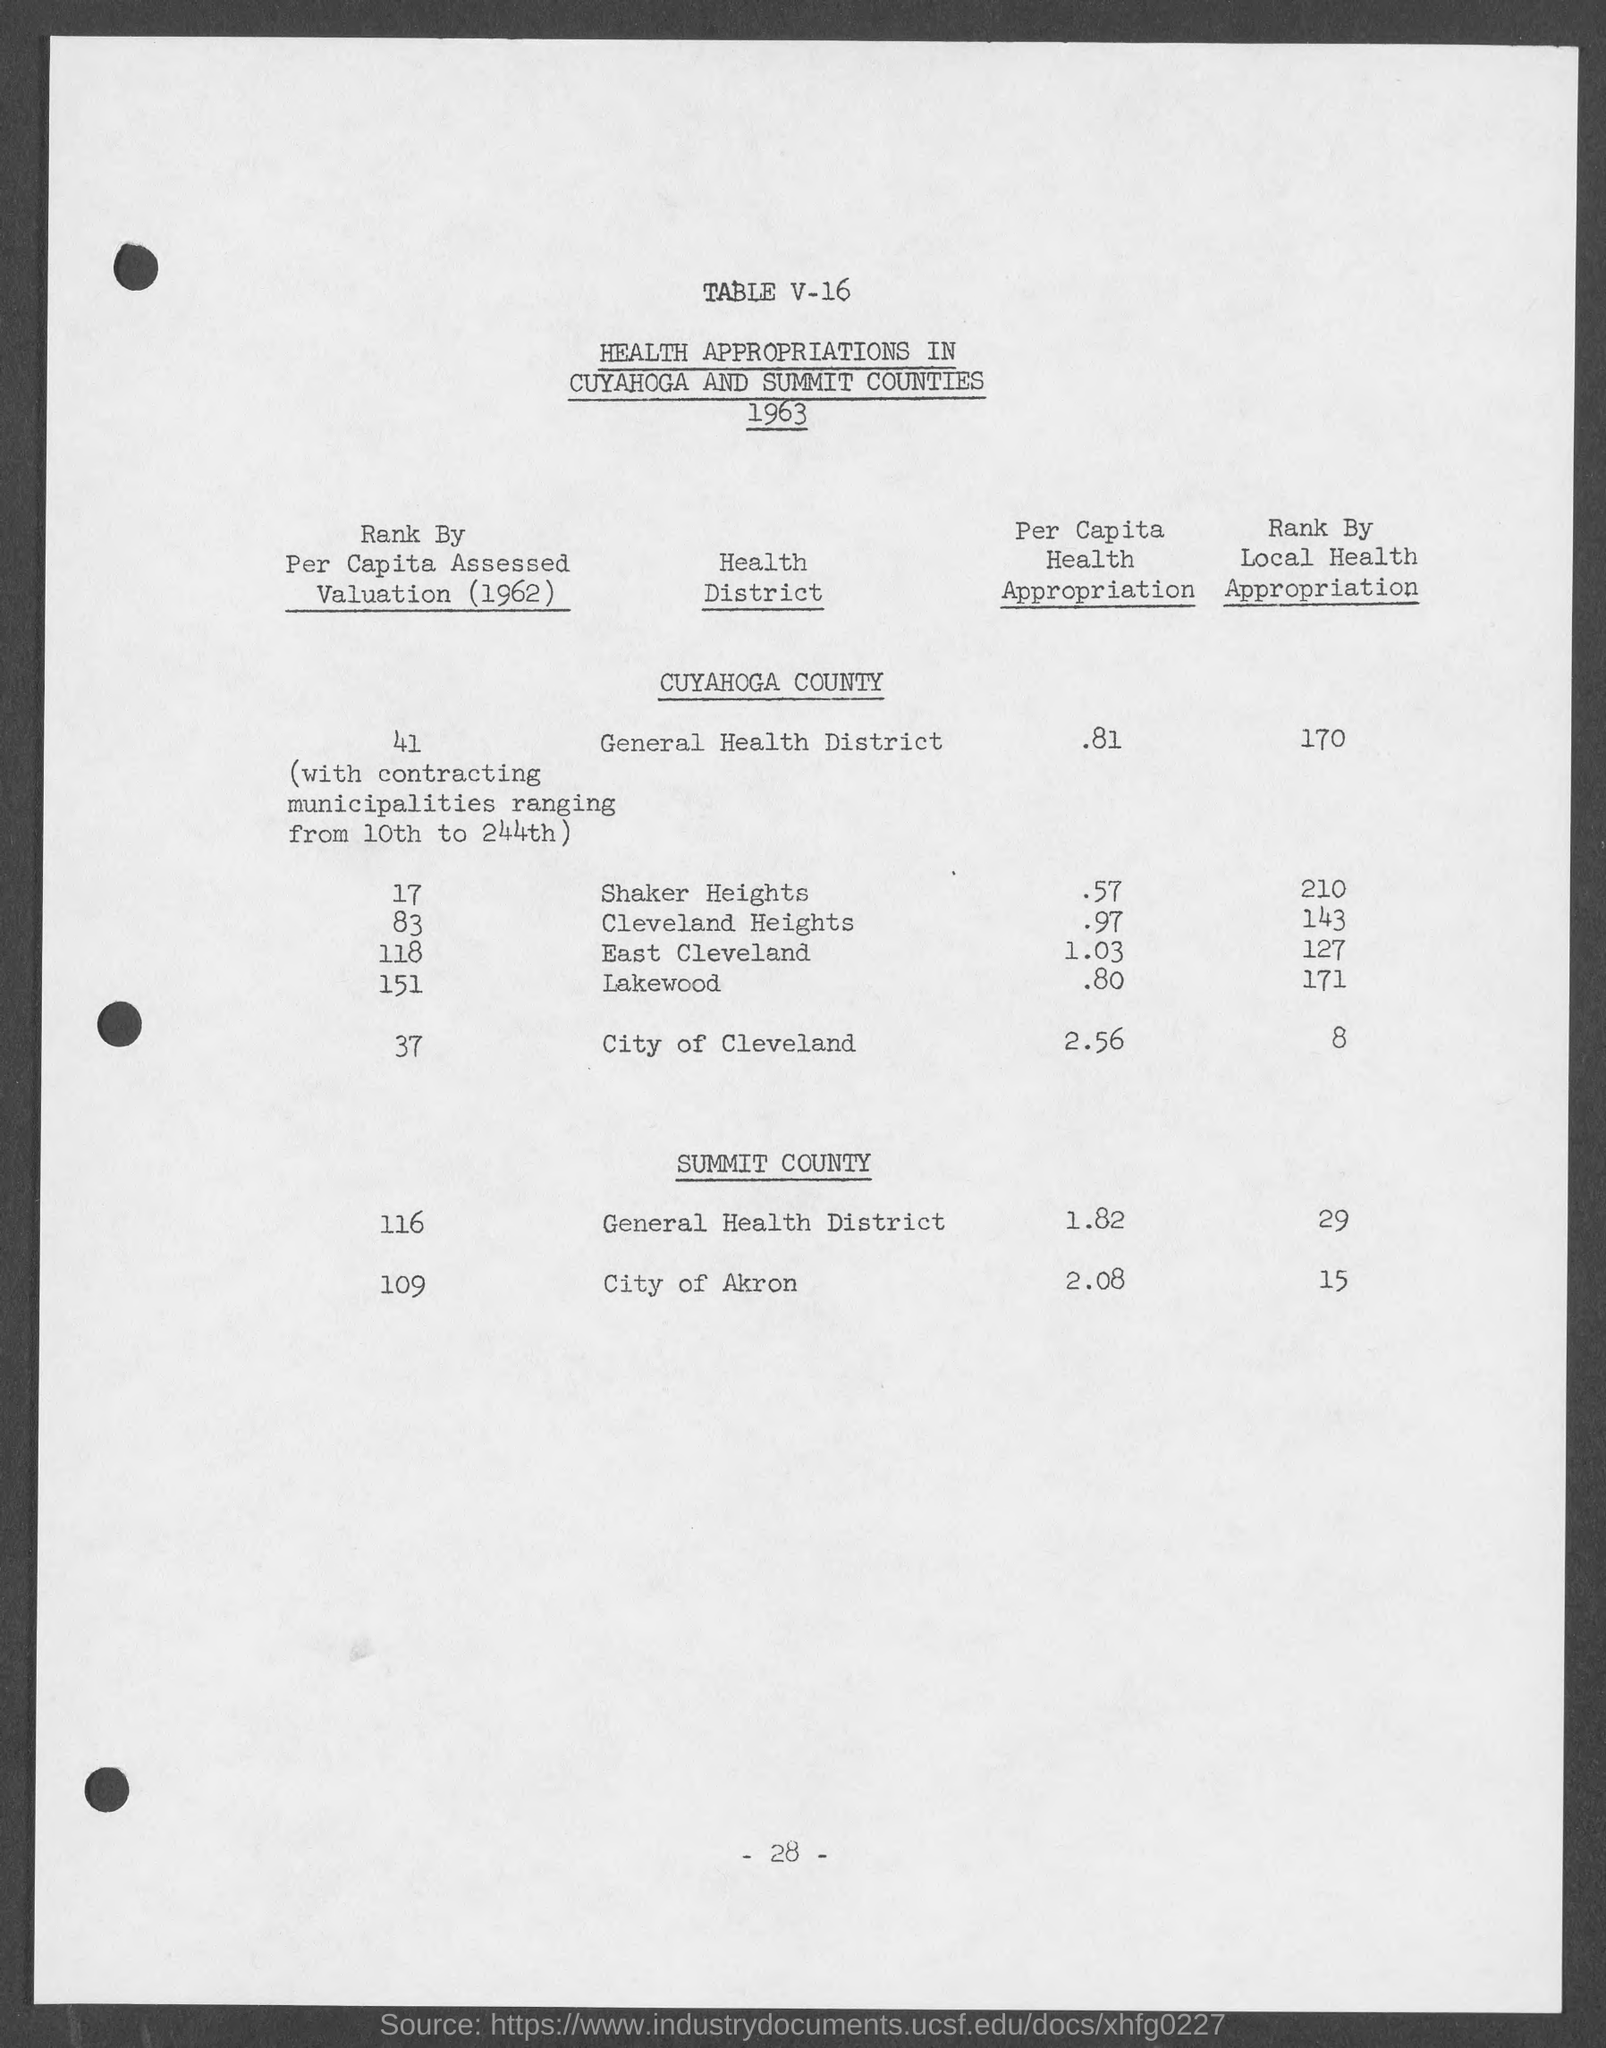Draw attention to some important aspects in this diagram. The per capita health appropriation for the general health district in Summit County is 1.82. The amount of money allocated for the health of each person in the City of Cleveland is 2.56... The per capita health appropriation for the general health district in Cuyahoga County is $0.81. The per capita health appropriation for East Cleveland is 1.03. The per capita health appropriation for Cleveland Heights is 0.97. 